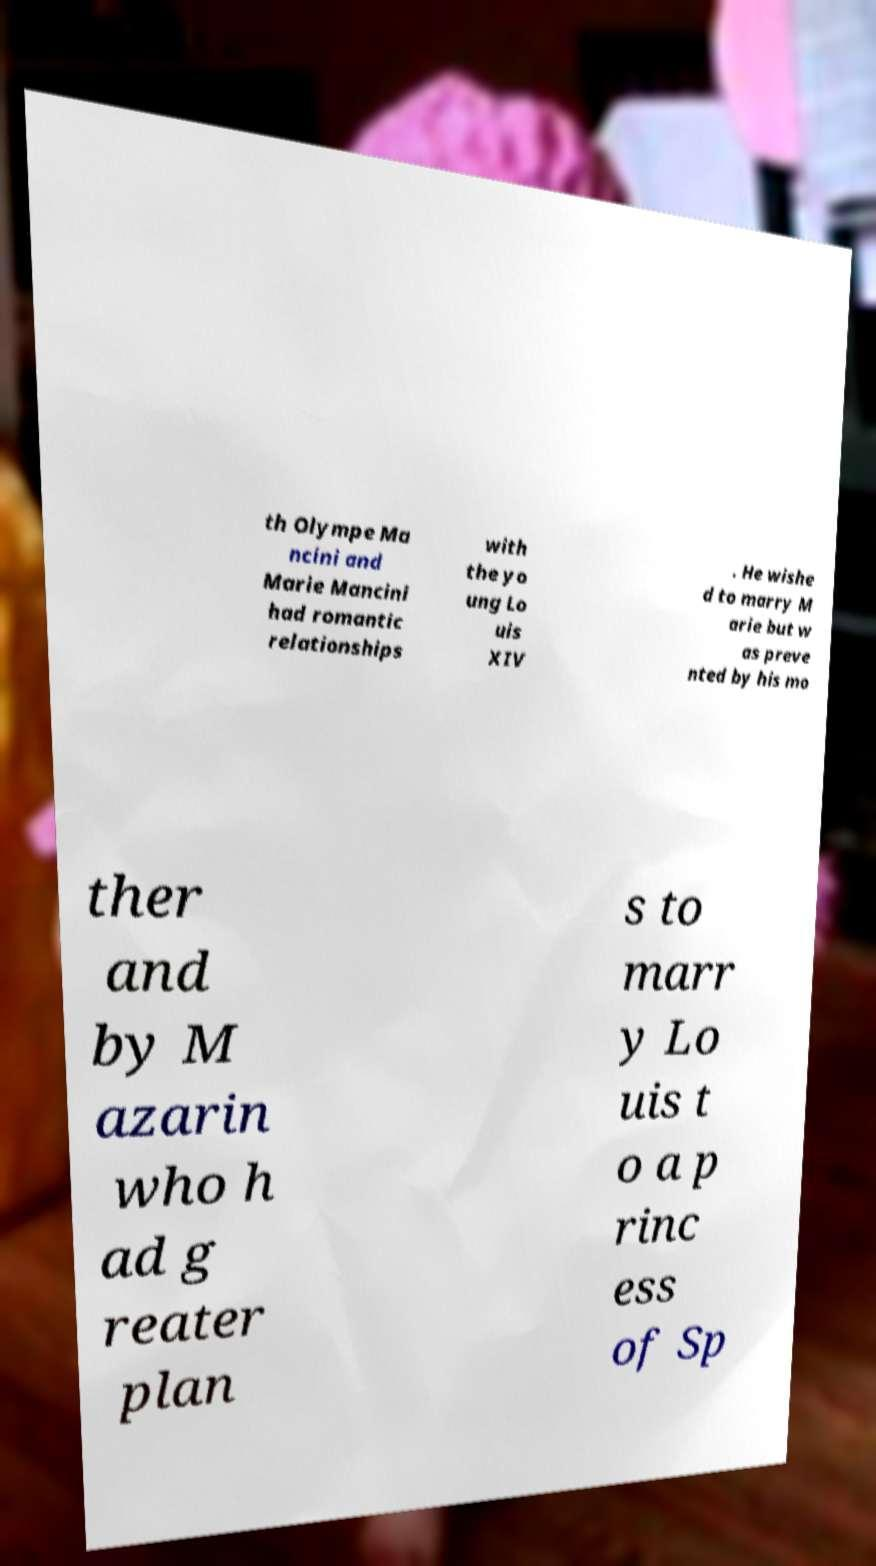Could you extract and type out the text from this image? th Olympe Ma ncini and Marie Mancini had romantic relationships with the yo ung Lo uis XIV . He wishe d to marry M arie but w as preve nted by his mo ther and by M azarin who h ad g reater plan s to marr y Lo uis t o a p rinc ess of Sp 